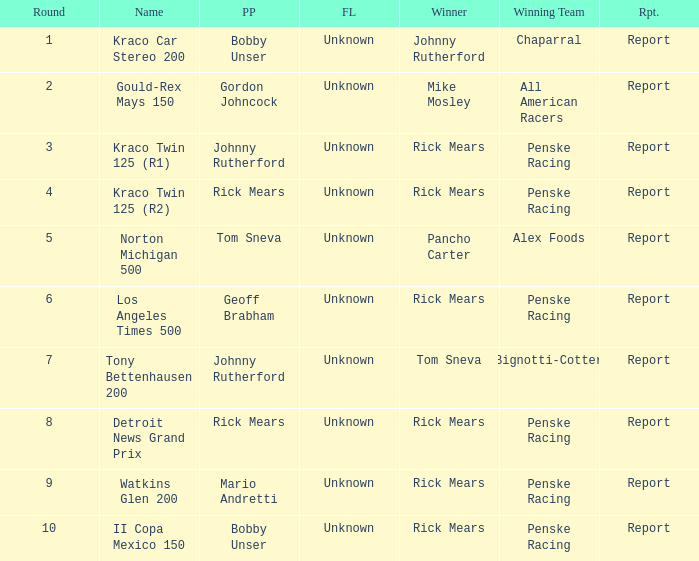How many winning drivers in the kraco twin 125 (r2) race were there? 1.0. 